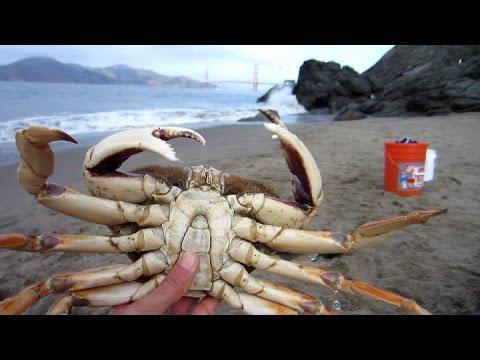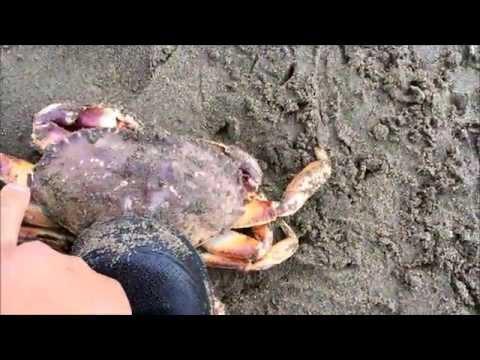The first image is the image on the left, the second image is the image on the right. Analyze the images presented: Is the assertion "Each image includes a hand near one crab, and one image shows a bare hand grasping a crab and holding it up in front of a body of water." valid? Answer yes or no. Yes. The first image is the image on the left, the second image is the image on the right. Assess this claim about the two images: "A person is holding a crab in the image on the left.". Correct or not? Answer yes or no. Yes. 